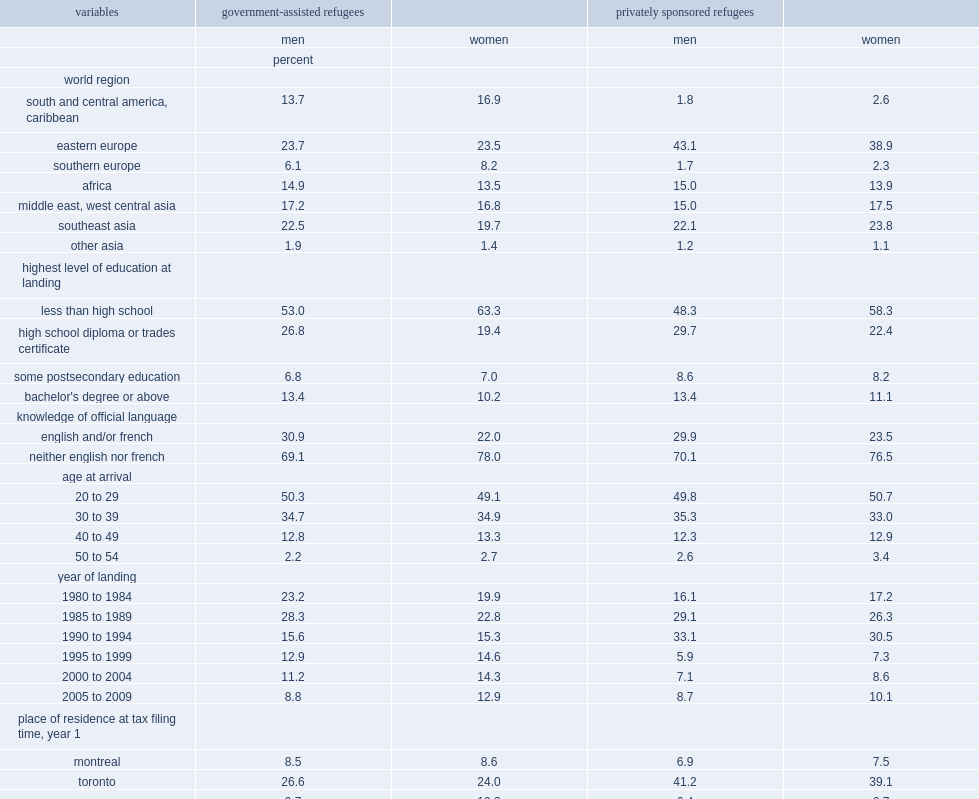What percent of refugees with less than a high school education are for male and female gars, respectively? 53.0 63.3. What percent of psrs initially settled in toronto? 41.2 39.1. 